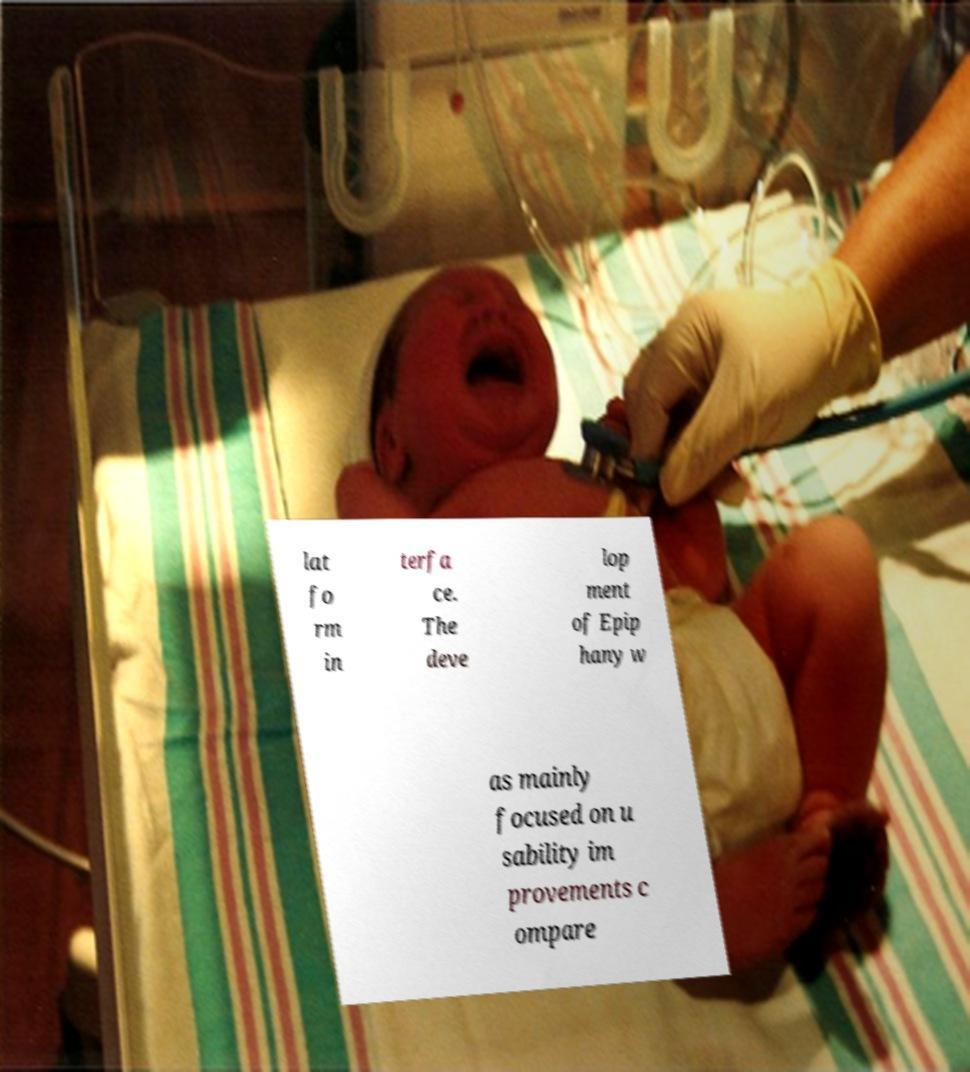For documentation purposes, I need the text within this image transcribed. Could you provide that? lat fo rm in terfa ce. The deve lop ment of Epip hany w as mainly focused on u sability im provements c ompare 